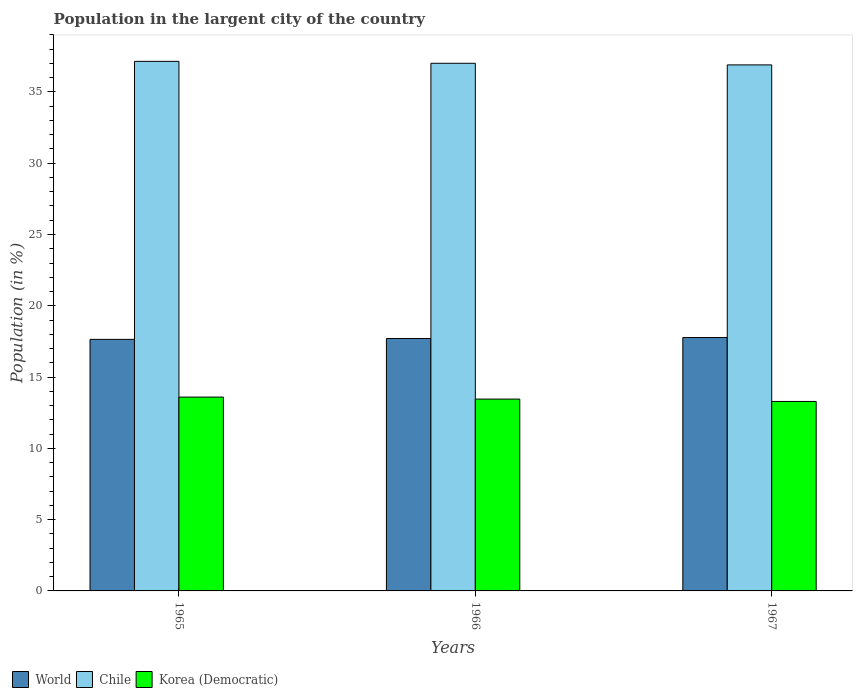How many groups of bars are there?
Give a very brief answer. 3. How many bars are there on the 1st tick from the left?
Make the answer very short. 3. How many bars are there on the 2nd tick from the right?
Ensure brevity in your answer.  3. What is the label of the 2nd group of bars from the left?
Offer a very short reply. 1966. In how many cases, is the number of bars for a given year not equal to the number of legend labels?
Keep it short and to the point. 0. What is the percentage of population in the largent city in Korea (Democratic) in 1966?
Make the answer very short. 13.46. Across all years, what is the maximum percentage of population in the largent city in Korea (Democratic)?
Your answer should be compact. 13.6. Across all years, what is the minimum percentage of population in the largent city in World?
Your answer should be compact. 17.64. In which year was the percentage of population in the largent city in World maximum?
Offer a very short reply. 1967. In which year was the percentage of population in the largent city in Korea (Democratic) minimum?
Your answer should be very brief. 1967. What is the total percentage of population in the largent city in World in the graph?
Offer a terse response. 53.12. What is the difference between the percentage of population in the largent city in World in 1965 and that in 1966?
Provide a succinct answer. -0.06. What is the difference between the percentage of population in the largent city in World in 1965 and the percentage of population in the largent city in Korea (Democratic) in 1966?
Your answer should be very brief. 4.19. What is the average percentage of population in the largent city in World per year?
Give a very brief answer. 17.71. In the year 1966, what is the difference between the percentage of population in the largent city in World and percentage of population in the largent city in Korea (Democratic)?
Offer a very short reply. 4.25. In how many years, is the percentage of population in the largent city in Chile greater than 5 %?
Give a very brief answer. 3. What is the ratio of the percentage of population in the largent city in World in 1966 to that in 1967?
Provide a succinct answer. 1. Is the difference between the percentage of population in the largent city in World in 1966 and 1967 greater than the difference between the percentage of population in the largent city in Korea (Democratic) in 1966 and 1967?
Your response must be concise. No. What is the difference between the highest and the second highest percentage of population in the largent city in Korea (Democratic)?
Offer a very short reply. 0.14. What is the difference between the highest and the lowest percentage of population in the largent city in Chile?
Give a very brief answer. 0.25. In how many years, is the percentage of population in the largent city in Chile greater than the average percentage of population in the largent city in Chile taken over all years?
Ensure brevity in your answer.  1. Is the sum of the percentage of population in the largent city in Korea (Democratic) in 1965 and 1967 greater than the maximum percentage of population in the largent city in World across all years?
Offer a very short reply. Yes. What does the 1st bar from the left in 1967 represents?
Provide a succinct answer. World. What does the 1st bar from the right in 1967 represents?
Provide a short and direct response. Korea (Democratic). What is the difference between two consecutive major ticks on the Y-axis?
Provide a short and direct response. 5. How many legend labels are there?
Keep it short and to the point. 3. What is the title of the graph?
Make the answer very short. Population in the largent city of the country. Does "Antigua and Barbuda" appear as one of the legend labels in the graph?
Provide a succinct answer. No. What is the label or title of the X-axis?
Offer a very short reply. Years. What is the label or title of the Y-axis?
Provide a short and direct response. Population (in %). What is the Population (in %) in World in 1965?
Keep it short and to the point. 17.64. What is the Population (in %) in Chile in 1965?
Keep it short and to the point. 37.15. What is the Population (in %) of Korea (Democratic) in 1965?
Keep it short and to the point. 13.6. What is the Population (in %) of World in 1966?
Offer a very short reply. 17.7. What is the Population (in %) of Chile in 1966?
Your response must be concise. 37.01. What is the Population (in %) in Korea (Democratic) in 1966?
Your response must be concise. 13.46. What is the Population (in %) in World in 1967?
Provide a succinct answer. 17.77. What is the Population (in %) in Chile in 1967?
Make the answer very short. 36.9. What is the Population (in %) of Korea (Democratic) in 1967?
Your answer should be very brief. 13.29. Across all years, what is the maximum Population (in %) in World?
Your answer should be very brief. 17.77. Across all years, what is the maximum Population (in %) in Chile?
Offer a very short reply. 37.15. Across all years, what is the maximum Population (in %) of Korea (Democratic)?
Ensure brevity in your answer.  13.6. Across all years, what is the minimum Population (in %) of World?
Your response must be concise. 17.64. Across all years, what is the minimum Population (in %) of Chile?
Your response must be concise. 36.9. Across all years, what is the minimum Population (in %) of Korea (Democratic)?
Offer a very short reply. 13.29. What is the total Population (in %) of World in the graph?
Your response must be concise. 53.12. What is the total Population (in %) in Chile in the graph?
Make the answer very short. 111.05. What is the total Population (in %) in Korea (Democratic) in the graph?
Keep it short and to the point. 40.34. What is the difference between the Population (in %) in World in 1965 and that in 1966?
Offer a very short reply. -0.06. What is the difference between the Population (in %) of Chile in 1965 and that in 1966?
Your answer should be compact. 0.13. What is the difference between the Population (in %) in Korea (Democratic) in 1965 and that in 1966?
Your answer should be very brief. 0.14. What is the difference between the Population (in %) in World in 1965 and that in 1967?
Provide a succinct answer. -0.13. What is the difference between the Population (in %) in Chile in 1965 and that in 1967?
Offer a terse response. 0.25. What is the difference between the Population (in %) in Korea (Democratic) in 1965 and that in 1967?
Your response must be concise. 0.31. What is the difference between the Population (in %) of World in 1966 and that in 1967?
Make the answer very short. -0.07. What is the difference between the Population (in %) in Chile in 1966 and that in 1967?
Provide a succinct answer. 0.11. What is the difference between the Population (in %) in Korea (Democratic) in 1966 and that in 1967?
Give a very brief answer. 0.17. What is the difference between the Population (in %) in World in 1965 and the Population (in %) in Chile in 1966?
Offer a very short reply. -19.37. What is the difference between the Population (in %) of World in 1965 and the Population (in %) of Korea (Democratic) in 1966?
Your answer should be compact. 4.19. What is the difference between the Population (in %) of Chile in 1965 and the Population (in %) of Korea (Democratic) in 1966?
Provide a succinct answer. 23.69. What is the difference between the Population (in %) in World in 1965 and the Population (in %) in Chile in 1967?
Provide a succinct answer. -19.25. What is the difference between the Population (in %) in World in 1965 and the Population (in %) in Korea (Democratic) in 1967?
Your answer should be very brief. 4.35. What is the difference between the Population (in %) in Chile in 1965 and the Population (in %) in Korea (Democratic) in 1967?
Keep it short and to the point. 23.86. What is the difference between the Population (in %) of World in 1966 and the Population (in %) of Chile in 1967?
Give a very brief answer. -19.19. What is the difference between the Population (in %) of World in 1966 and the Population (in %) of Korea (Democratic) in 1967?
Your answer should be very brief. 4.41. What is the difference between the Population (in %) in Chile in 1966 and the Population (in %) in Korea (Democratic) in 1967?
Offer a very short reply. 23.72. What is the average Population (in %) of World per year?
Provide a short and direct response. 17.71. What is the average Population (in %) in Chile per year?
Your answer should be very brief. 37.02. What is the average Population (in %) of Korea (Democratic) per year?
Your response must be concise. 13.45. In the year 1965, what is the difference between the Population (in %) of World and Population (in %) of Chile?
Provide a succinct answer. -19.5. In the year 1965, what is the difference between the Population (in %) in World and Population (in %) in Korea (Democratic)?
Give a very brief answer. 4.05. In the year 1965, what is the difference between the Population (in %) of Chile and Population (in %) of Korea (Democratic)?
Offer a terse response. 23.55. In the year 1966, what is the difference between the Population (in %) in World and Population (in %) in Chile?
Your answer should be compact. -19.31. In the year 1966, what is the difference between the Population (in %) of World and Population (in %) of Korea (Democratic)?
Your response must be concise. 4.25. In the year 1966, what is the difference between the Population (in %) of Chile and Population (in %) of Korea (Democratic)?
Provide a short and direct response. 23.55. In the year 1967, what is the difference between the Population (in %) of World and Population (in %) of Chile?
Your answer should be compact. -19.12. In the year 1967, what is the difference between the Population (in %) in World and Population (in %) in Korea (Democratic)?
Give a very brief answer. 4.48. In the year 1967, what is the difference between the Population (in %) in Chile and Population (in %) in Korea (Democratic)?
Offer a terse response. 23.61. What is the ratio of the Population (in %) in World in 1965 to that in 1966?
Provide a succinct answer. 1. What is the ratio of the Population (in %) of Chile in 1965 to that in 1966?
Ensure brevity in your answer.  1. What is the ratio of the Population (in %) of Korea (Democratic) in 1965 to that in 1966?
Your answer should be compact. 1.01. What is the ratio of the Population (in %) of World in 1966 to that in 1967?
Your answer should be compact. 1. What is the ratio of the Population (in %) in Korea (Democratic) in 1966 to that in 1967?
Give a very brief answer. 1.01. What is the difference between the highest and the second highest Population (in %) of World?
Keep it short and to the point. 0.07. What is the difference between the highest and the second highest Population (in %) in Chile?
Provide a short and direct response. 0.13. What is the difference between the highest and the second highest Population (in %) of Korea (Democratic)?
Give a very brief answer. 0.14. What is the difference between the highest and the lowest Population (in %) in World?
Make the answer very short. 0.13. What is the difference between the highest and the lowest Population (in %) in Chile?
Provide a succinct answer. 0.25. What is the difference between the highest and the lowest Population (in %) in Korea (Democratic)?
Provide a short and direct response. 0.31. 